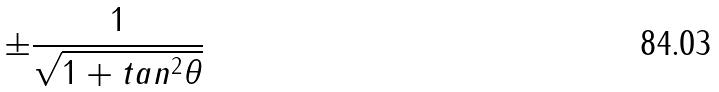Convert formula to latex. <formula><loc_0><loc_0><loc_500><loc_500>\pm \frac { 1 } { \sqrt { 1 + t a n ^ { 2 } \theta } }</formula> 